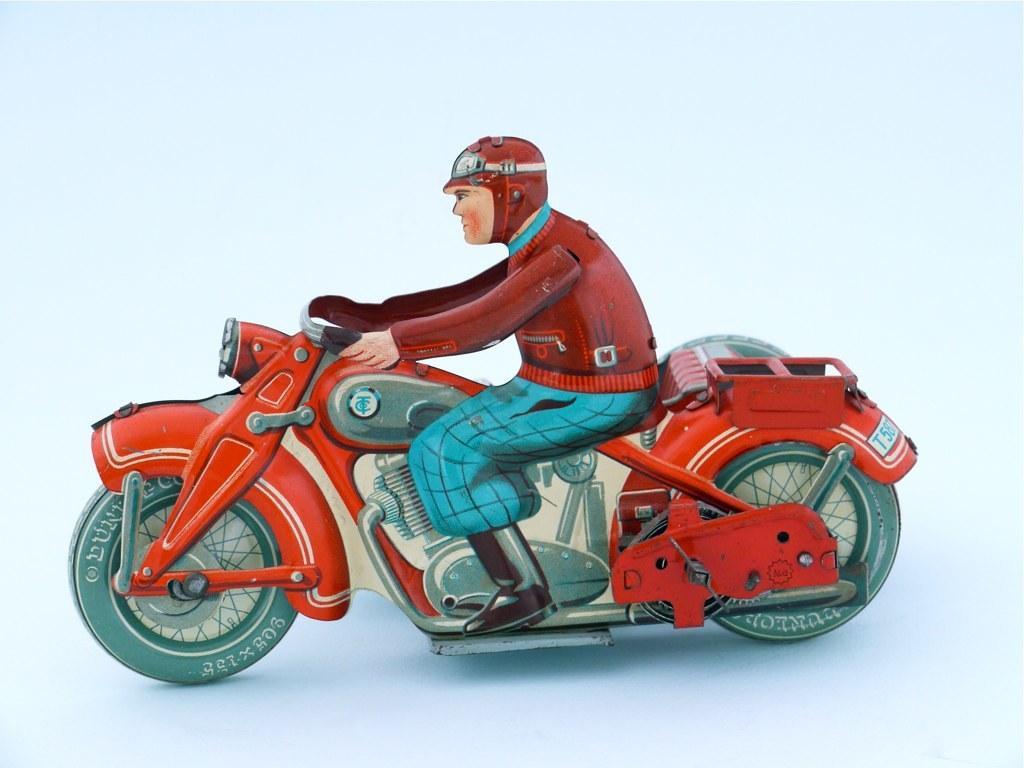How would you summarize this image in a sentence or two? In this picture we can see the drawing of a man wearing a helmet and sitting on a red colored bike. 